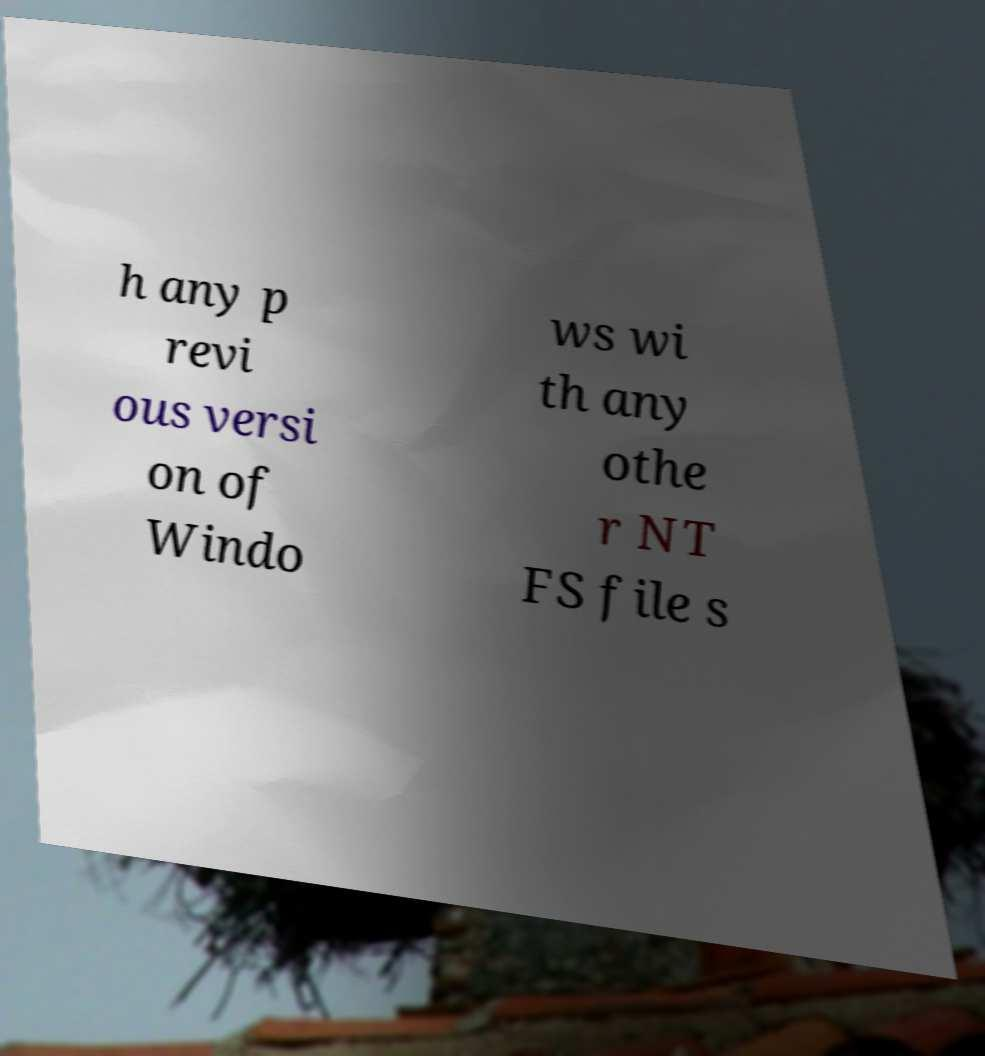There's text embedded in this image that I need extracted. Can you transcribe it verbatim? h any p revi ous versi on of Windo ws wi th any othe r NT FS file s 